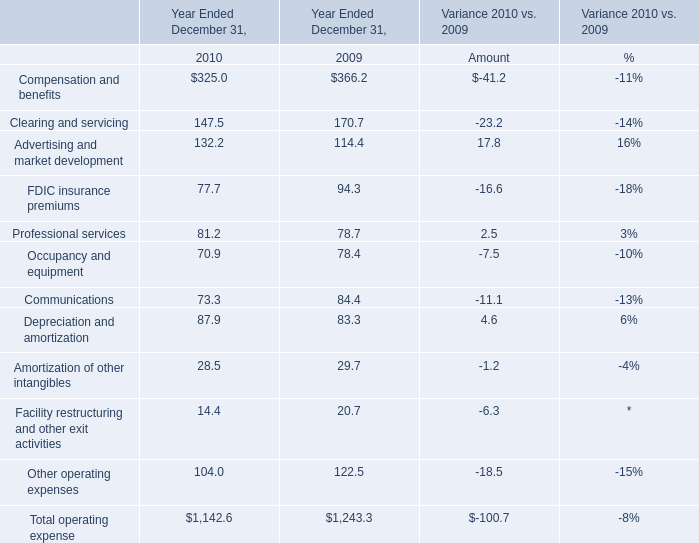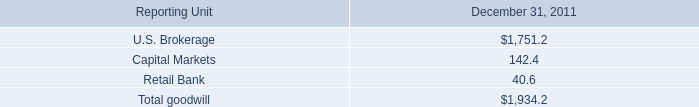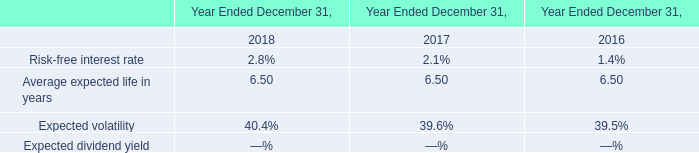What is the sum of Compensation and benefits in 2010 and Average expected life in years in 2018 ? 
Computations: (325 + 6.5)
Answer: 331.5. 